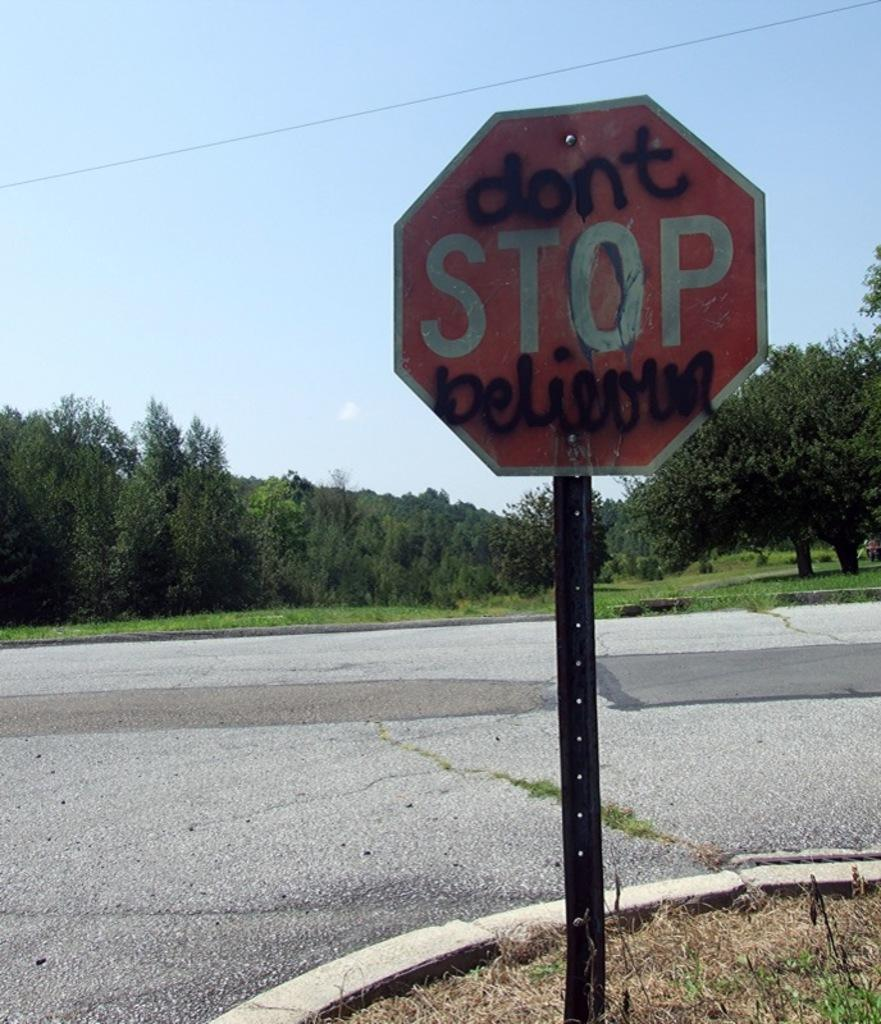<image>
Give a short and clear explanation of the subsequent image. A stop sign has been altered to say "don't stop believing." 